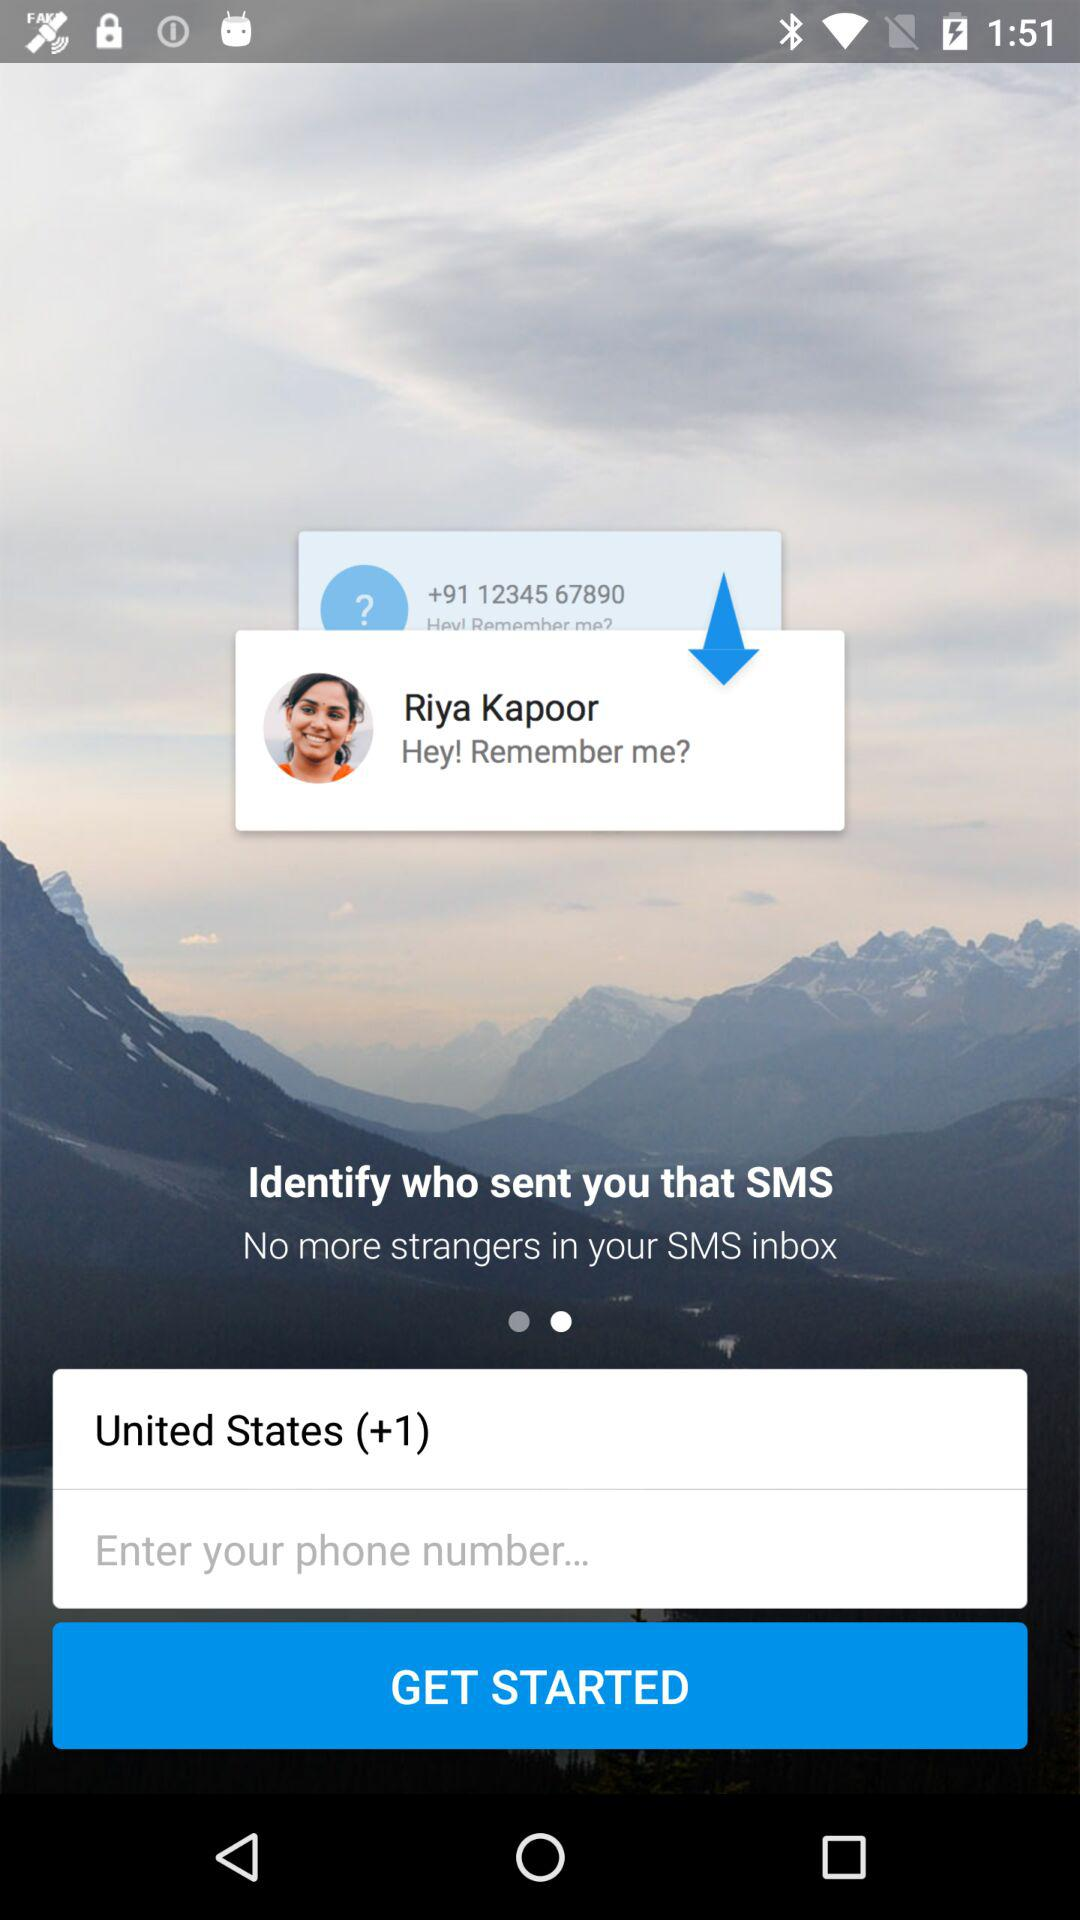What is the location? The location is "United States". 